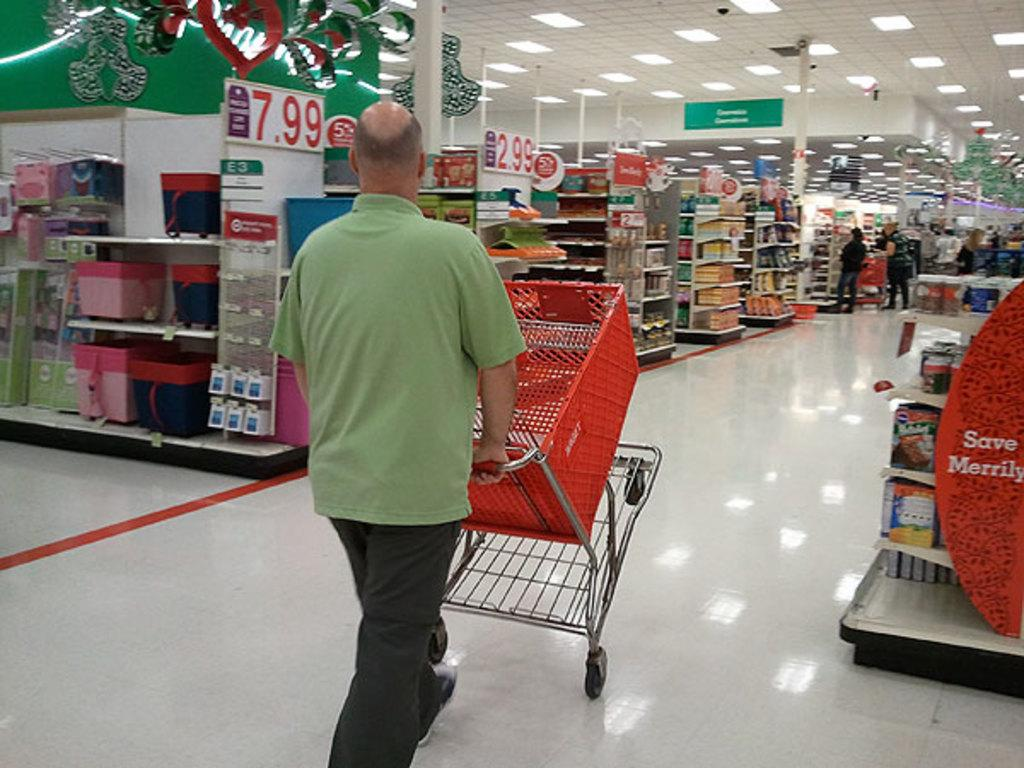<image>
Create a compact narrative representing the image presented. A man is doing a wheely with his shopping cart next to a sign that says "save merrily". 